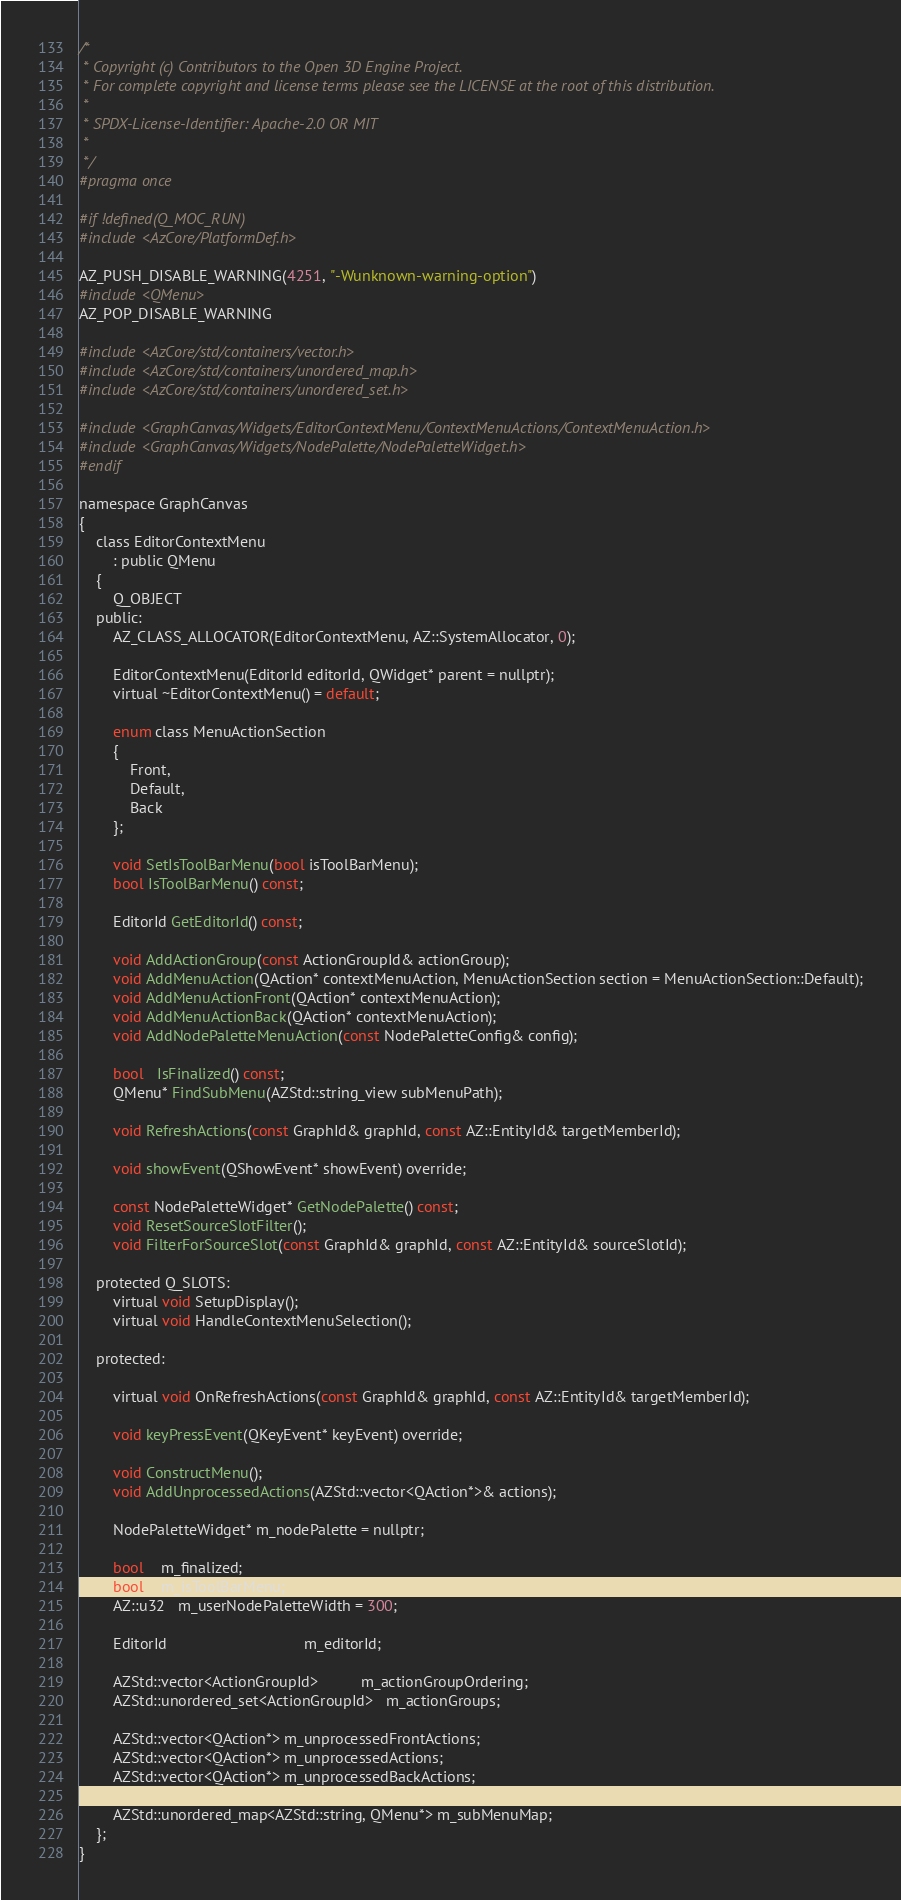<code> <loc_0><loc_0><loc_500><loc_500><_C_>/*
 * Copyright (c) Contributors to the Open 3D Engine Project.
 * For complete copyright and license terms please see the LICENSE at the root of this distribution.
 *
 * SPDX-License-Identifier: Apache-2.0 OR MIT
 *
 */
#pragma once

#if !defined(Q_MOC_RUN)
#include <AzCore/PlatformDef.h>

AZ_PUSH_DISABLE_WARNING(4251, "-Wunknown-warning-option")
#include <QMenu>
AZ_POP_DISABLE_WARNING

#include <AzCore/std/containers/vector.h>
#include <AzCore/std/containers/unordered_map.h>
#include <AzCore/std/containers/unordered_set.h>

#include <GraphCanvas/Widgets/EditorContextMenu/ContextMenuActions/ContextMenuAction.h>
#include <GraphCanvas/Widgets/NodePalette/NodePaletteWidget.h>
#endif

namespace GraphCanvas
{
    class EditorContextMenu
        : public QMenu
    {
        Q_OBJECT
    public:    
        AZ_CLASS_ALLOCATOR(EditorContextMenu, AZ::SystemAllocator, 0);
        
        EditorContextMenu(EditorId editorId, QWidget* parent = nullptr);
        virtual ~EditorContextMenu() = default;

        enum class MenuActionSection
        {
            Front,
            Default,
            Back
        };

        void SetIsToolBarMenu(bool isToolBarMenu);
        bool IsToolBarMenu() const;

        EditorId GetEditorId() const;

        void AddActionGroup(const ActionGroupId& actionGroup);
        void AddMenuAction(QAction* contextMenuAction, MenuActionSection section = MenuActionSection::Default);
        void AddMenuActionFront(QAction* contextMenuAction);
        void AddMenuActionBack(QAction* contextMenuAction);
        void AddNodePaletteMenuAction(const NodePaletteConfig& config);       

        bool   IsFinalized() const;
        QMenu* FindSubMenu(AZStd::string_view subMenuPath);

        void RefreshActions(const GraphId& graphId, const AZ::EntityId& targetMemberId);
        
        void showEvent(QShowEvent* showEvent) override;

        const NodePaletteWidget* GetNodePalette() const;
        void ResetSourceSlotFilter();
        void FilterForSourceSlot(const GraphId& graphId, const AZ::EntityId& sourceSlotId);

    protected Q_SLOTS:
        virtual void SetupDisplay();
        virtual void HandleContextMenuSelection();

    protected:

        virtual void OnRefreshActions(const GraphId& graphId, const AZ::EntityId& targetMemberId);

        void keyPressEvent(QKeyEvent* keyEvent) override;

        void ConstructMenu();
        void AddUnprocessedActions(AZStd::vector<QAction*>& actions);
    
        NodePaletteWidget* m_nodePalette = nullptr;

        bool    m_finalized;
        bool    m_isToolBarMenu;
        AZ::u32   m_userNodePaletteWidth = 300;

        EditorId                                m_editorId;

        AZStd::vector<ActionGroupId>          m_actionGroupOrdering;
        AZStd::unordered_set<ActionGroupId>   m_actionGroups;

        AZStd::vector<QAction*> m_unprocessedFrontActions;
        AZStd::vector<QAction*> m_unprocessedActions;
        AZStd::vector<QAction*> m_unprocessedBackActions;

        AZStd::unordered_map<AZStd::string, QMenu*> m_subMenuMap;
    };
}
</code> 